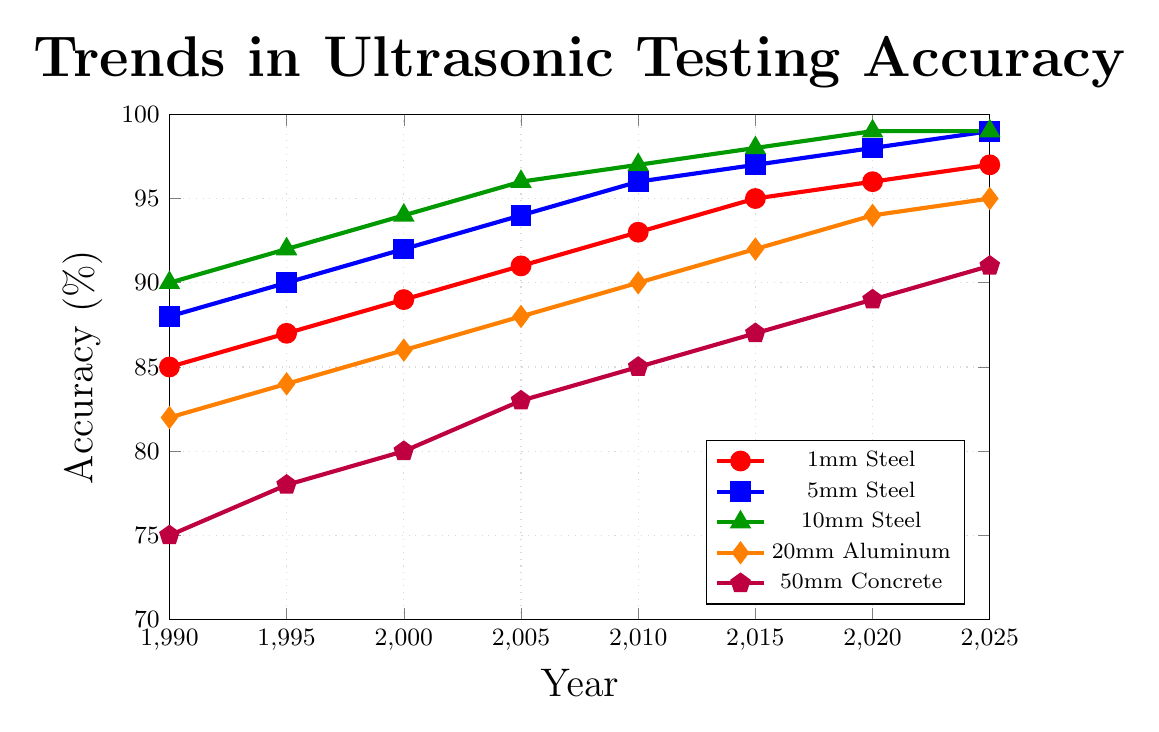What is the overall trend of ultrasonic testing accuracy for 1mm Steel over the years? The ultrasonic testing accuracy for 1mm Steel shows a steadily increasing trend, starting from 85% in 1990 and reaching 97% in 2025.
Answer: Increasing Which material shows the highest accuracy in 2010? By comparing the data points for all materials in 2010, we see that 10mm Steel has the highest accuracy at 97%.
Answer: 10mm Steel Which material had the lowest accuracy in 1995, and what was its value? In 1995, the lowest accuracy among the materials was for 50mm Concrete at 78%.
Answer: 50mm Concrete, 78% What is the average increase in accuracy for 5mm Steel from 1990 to 2025? The accuracy for 5mm Steel increased from 88% in 1990 to 99% in 2025, which is an increase of 11%. Over 35 years, the average increase per year is 11/35 ≈ 0.314%.
Answer: 0.314% per year In which year did 20mm Aluminum reach an accuracy of 90%? By looking at the trend for 20mm Aluminum, we see that it reached an accuracy of 90% in 2010.
Answer: 2010 Compare the accuracy of 5mm Steel and 20mm Aluminum in the year 2000. Which was higher and by how much? In the year 2000, the accuracy for 5mm Steel was 92%, and for 20mm Aluminum, it was 86%. The 5mm Steel accuracy was higher by 92 - 86 = 6%.
Answer: 5mm Steel, 6% By how much did the accuracy of 50mm Concrete increase from 1990 to 2010? The accuracy for 50mm Concrete increased from 75% in 1990 to 85% in 2010, which is an increase of 10%.
Answer: 10% Which material had the smallest overall improvement in accuracy from 1990 to 2025? By calculating the overall improvement for each material, we see that 1mm Steel increased from 85% to 97% (+12%), 5mm Steel from 88% to 99% (+11%), 10mm Steel from 90% to 99% (+9%), 20mm Aluminum from 82% to 95% (+13%), and 50mm Concrete from 75% to 91% (+16%). Thus, 10mm Steel had the smallest improvement at +9%.
Answer: 10mm Steel What is the difference in accuracy between 1mm Steel and 50mm Concrete in 2025? In 2025, the accuracy for 1mm Steel is 97% and that for 50mm Concrete is 91%. The difference is 97 - 91 = 6%.
Answer: 6% Which material is represented by the orange line, and what is its accuracy in 2000? The orange line represents 20mm Aluminum, and its accuracy in 2000 is 86%.
Answer: 20mm Aluminum, 86% 